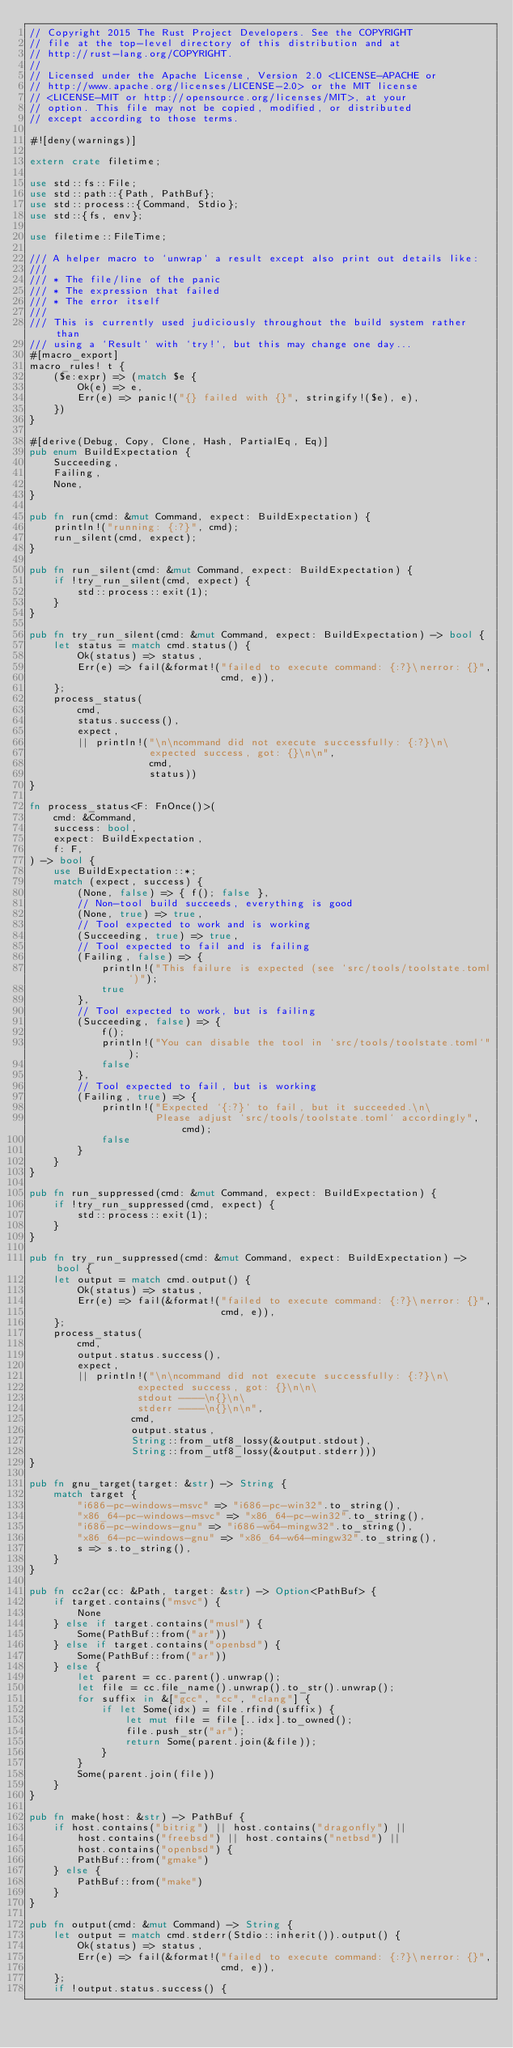Convert code to text. <code><loc_0><loc_0><loc_500><loc_500><_Rust_>// Copyright 2015 The Rust Project Developers. See the COPYRIGHT
// file at the top-level directory of this distribution and at
// http://rust-lang.org/COPYRIGHT.
//
// Licensed under the Apache License, Version 2.0 <LICENSE-APACHE or
// http://www.apache.org/licenses/LICENSE-2.0> or the MIT license
// <LICENSE-MIT or http://opensource.org/licenses/MIT>, at your
// option. This file may not be copied, modified, or distributed
// except according to those terms.

#![deny(warnings)]

extern crate filetime;

use std::fs::File;
use std::path::{Path, PathBuf};
use std::process::{Command, Stdio};
use std::{fs, env};

use filetime::FileTime;

/// A helper macro to `unwrap` a result except also print out details like:
///
/// * The file/line of the panic
/// * The expression that failed
/// * The error itself
///
/// This is currently used judiciously throughout the build system rather than
/// using a `Result` with `try!`, but this may change one day...
#[macro_export]
macro_rules! t {
    ($e:expr) => (match $e {
        Ok(e) => e,
        Err(e) => panic!("{} failed with {}", stringify!($e), e),
    })
}

#[derive(Debug, Copy, Clone, Hash, PartialEq, Eq)]
pub enum BuildExpectation {
    Succeeding,
    Failing,
    None,
}

pub fn run(cmd: &mut Command, expect: BuildExpectation) {
    println!("running: {:?}", cmd);
    run_silent(cmd, expect);
}

pub fn run_silent(cmd: &mut Command, expect: BuildExpectation) {
    if !try_run_silent(cmd, expect) {
        std::process::exit(1);
    }
}

pub fn try_run_silent(cmd: &mut Command, expect: BuildExpectation) -> bool {
    let status = match cmd.status() {
        Ok(status) => status,
        Err(e) => fail(&format!("failed to execute command: {:?}\nerror: {}",
                                cmd, e)),
    };
    process_status(
        cmd,
        status.success(),
        expect,
        || println!("\n\ncommand did not execute successfully: {:?}\n\
                    expected success, got: {}\n\n",
                    cmd,
                    status))
}

fn process_status<F: FnOnce()>(
    cmd: &Command,
    success: bool,
    expect: BuildExpectation,
    f: F,
) -> bool {
    use BuildExpectation::*;
    match (expect, success) {
        (None, false) => { f(); false },
        // Non-tool build succeeds, everything is good
        (None, true) => true,
        // Tool expected to work and is working
        (Succeeding, true) => true,
        // Tool expected to fail and is failing
        (Failing, false) => {
            println!("This failure is expected (see `src/tools/toolstate.toml`)");
            true
        },
        // Tool expected to work, but is failing
        (Succeeding, false) => {
            f();
            println!("You can disable the tool in `src/tools/toolstate.toml`");
            false
        },
        // Tool expected to fail, but is working
        (Failing, true) => {
            println!("Expected `{:?}` to fail, but it succeeded.\n\
                     Please adjust `src/tools/toolstate.toml` accordingly", cmd);
            false
        }
    }
}

pub fn run_suppressed(cmd: &mut Command, expect: BuildExpectation) {
    if !try_run_suppressed(cmd, expect) {
        std::process::exit(1);
    }
}

pub fn try_run_suppressed(cmd: &mut Command, expect: BuildExpectation) -> bool {
    let output = match cmd.output() {
        Ok(status) => status,
        Err(e) => fail(&format!("failed to execute command: {:?}\nerror: {}",
                                cmd, e)),
    };
    process_status(
        cmd,
        output.status.success(),
        expect,
        || println!("\n\ncommand did not execute successfully: {:?}\n\
                  expected success, got: {}\n\n\
                  stdout ----\n{}\n\
                  stderr ----\n{}\n\n",
                 cmd,
                 output.status,
                 String::from_utf8_lossy(&output.stdout),
                 String::from_utf8_lossy(&output.stderr)))
}

pub fn gnu_target(target: &str) -> String {
    match target {
        "i686-pc-windows-msvc" => "i686-pc-win32".to_string(),
        "x86_64-pc-windows-msvc" => "x86_64-pc-win32".to_string(),
        "i686-pc-windows-gnu" => "i686-w64-mingw32".to_string(),
        "x86_64-pc-windows-gnu" => "x86_64-w64-mingw32".to_string(),
        s => s.to_string(),
    }
}

pub fn cc2ar(cc: &Path, target: &str) -> Option<PathBuf> {
    if target.contains("msvc") {
        None
    } else if target.contains("musl") {
        Some(PathBuf::from("ar"))
    } else if target.contains("openbsd") {
        Some(PathBuf::from("ar"))
    } else {
        let parent = cc.parent().unwrap();
        let file = cc.file_name().unwrap().to_str().unwrap();
        for suffix in &["gcc", "cc", "clang"] {
            if let Some(idx) = file.rfind(suffix) {
                let mut file = file[..idx].to_owned();
                file.push_str("ar");
                return Some(parent.join(&file));
            }
        }
        Some(parent.join(file))
    }
}

pub fn make(host: &str) -> PathBuf {
    if host.contains("bitrig") || host.contains("dragonfly") ||
        host.contains("freebsd") || host.contains("netbsd") ||
        host.contains("openbsd") {
        PathBuf::from("gmake")
    } else {
        PathBuf::from("make")
    }
}

pub fn output(cmd: &mut Command) -> String {
    let output = match cmd.stderr(Stdio::inherit()).output() {
        Ok(status) => status,
        Err(e) => fail(&format!("failed to execute command: {:?}\nerror: {}",
                                cmd, e)),
    };
    if !output.status.success() {</code> 